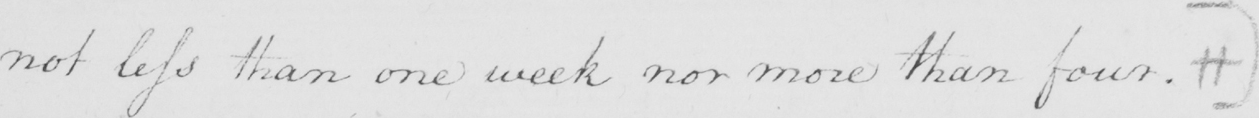What text is written in this handwritten line? not less than one week nor more than four .  +  +  ] 